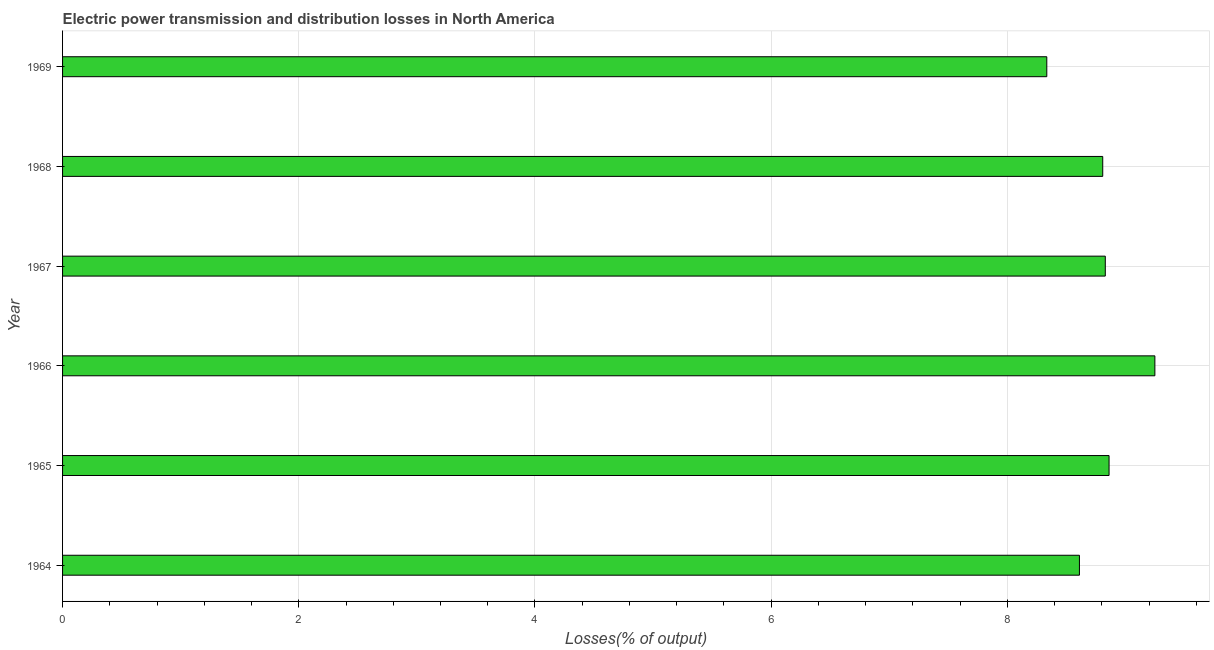Does the graph contain any zero values?
Your response must be concise. No. Does the graph contain grids?
Keep it short and to the point. Yes. What is the title of the graph?
Your answer should be very brief. Electric power transmission and distribution losses in North America. What is the label or title of the X-axis?
Your answer should be compact. Losses(% of output). What is the electric power transmission and distribution losses in 1969?
Provide a short and direct response. 8.33. Across all years, what is the maximum electric power transmission and distribution losses?
Make the answer very short. 9.25. Across all years, what is the minimum electric power transmission and distribution losses?
Keep it short and to the point. 8.33. In which year was the electric power transmission and distribution losses maximum?
Your answer should be very brief. 1966. In which year was the electric power transmission and distribution losses minimum?
Give a very brief answer. 1969. What is the sum of the electric power transmission and distribution losses?
Your answer should be compact. 52.69. What is the difference between the electric power transmission and distribution losses in 1964 and 1966?
Your answer should be very brief. -0.64. What is the average electric power transmission and distribution losses per year?
Ensure brevity in your answer.  8.78. What is the median electric power transmission and distribution losses?
Offer a very short reply. 8.82. In how many years, is the electric power transmission and distribution losses greater than 4.4 %?
Make the answer very short. 6. Do a majority of the years between 1966 and 1968 (inclusive) have electric power transmission and distribution losses greater than 3.6 %?
Give a very brief answer. Yes. What is the difference between the highest and the second highest electric power transmission and distribution losses?
Ensure brevity in your answer.  0.39. What is the difference between the highest and the lowest electric power transmission and distribution losses?
Give a very brief answer. 0.92. How many bars are there?
Provide a short and direct response. 6. How many years are there in the graph?
Keep it short and to the point. 6. What is the difference between two consecutive major ticks on the X-axis?
Ensure brevity in your answer.  2. Are the values on the major ticks of X-axis written in scientific E-notation?
Give a very brief answer. No. What is the Losses(% of output) of 1964?
Offer a terse response. 8.61. What is the Losses(% of output) of 1965?
Your response must be concise. 8.86. What is the Losses(% of output) in 1966?
Offer a very short reply. 9.25. What is the Losses(% of output) in 1967?
Provide a short and direct response. 8.83. What is the Losses(% of output) in 1968?
Your answer should be compact. 8.81. What is the Losses(% of output) in 1969?
Make the answer very short. 8.33. What is the difference between the Losses(% of output) in 1964 and 1965?
Offer a terse response. -0.25. What is the difference between the Losses(% of output) in 1964 and 1966?
Offer a terse response. -0.64. What is the difference between the Losses(% of output) in 1964 and 1967?
Your answer should be very brief. -0.22. What is the difference between the Losses(% of output) in 1964 and 1968?
Your answer should be compact. -0.2. What is the difference between the Losses(% of output) in 1964 and 1969?
Your answer should be compact. 0.28. What is the difference between the Losses(% of output) in 1965 and 1966?
Give a very brief answer. -0.39. What is the difference between the Losses(% of output) in 1965 and 1967?
Offer a terse response. 0.03. What is the difference between the Losses(% of output) in 1965 and 1968?
Provide a succinct answer. 0.05. What is the difference between the Losses(% of output) in 1965 and 1969?
Your answer should be compact. 0.53. What is the difference between the Losses(% of output) in 1966 and 1967?
Your answer should be compact. 0.42. What is the difference between the Losses(% of output) in 1966 and 1968?
Ensure brevity in your answer.  0.44. What is the difference between the Losses(% of output) in 1966 and 1969?
Your answer should be very brief. 0.92. What is the difference between the Losses(% of output) in 1967 and 1968?
Make the answer very short. 0.02. What is the difference between the Losses(% of output) in 1967 and 1969?
Your response must be concise. 0.5. What is the difference between the Losses(% of output) in 1968 and 1969?
Your answer should be compact. 0.47. What is the ratio of the Losses(% of output) in 1964 to that in 1965?
Give a very brief answer. 0.97. What is the ratio of the Losses(% of output) in 1964 to that in 1966?
Your answer should be compact. 0.93. What is the ratio of the Losses(% of output) in 1964 to that in 1969?
Provide a short and direct response. 1.03. What is the ratio of the Losses(% of output) in 1965 to that in 1966?
Keep it short and to the point. 0.96. What is the ratio of the Losses(% of output) in 1965 to that in 1969?
Make the answer very short. 1.06. What is the ratio of the Losses(% of output) in 1966 to that in 1967?
Your answer should be compact. 1.05. What is the ratio of the Losses(% of output) in 1966 to that in 1969?
Your response must be concise. 1.11. What is the ratio of the Losses(% of output) in 1967 to that in 1969?
Your answer should be very brief. 1.06. What is the ratio of the Losses(% of output) in 1968 to that in 1969?
Offer a terse response. 1.06. 